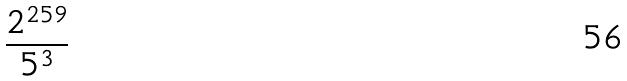<formula> <loc_0><loc_0><loc_500><loc_500>\frac { 2 ^ { 2 5 9 } } { 5 ^ { 3 } }</formula> 